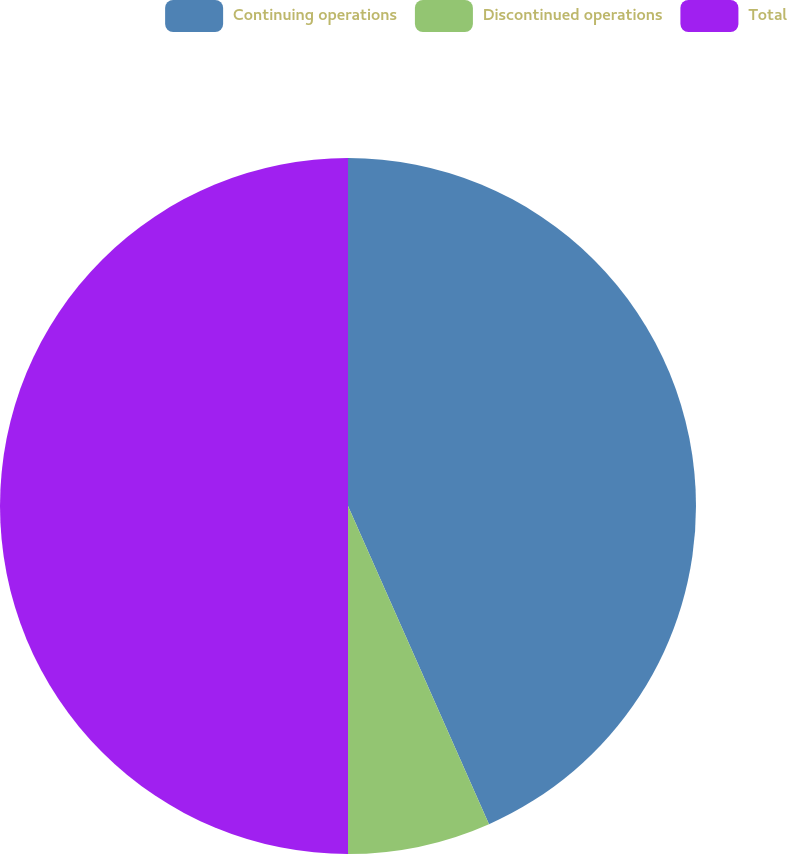<chart> <loc_0><loc_0><loc_500><loc_500><pie_chart><fcel>Continuing operations<fcel>Discontinued operations<fcel>Total<nl><fcel>43.36%<fcel>6.64%<fcel>50.0%<nl></chart> 